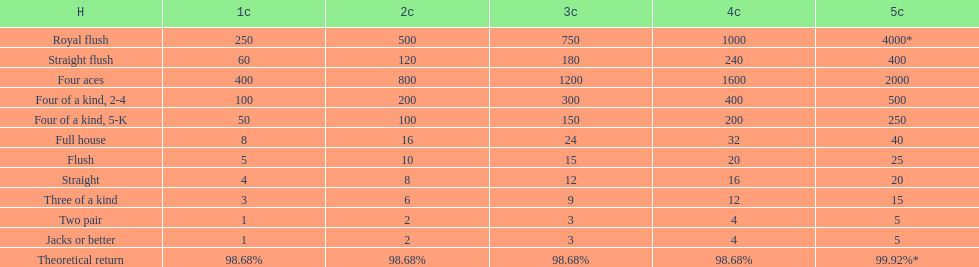Which is a higher standing hand: a straight or a flush? Flush. 